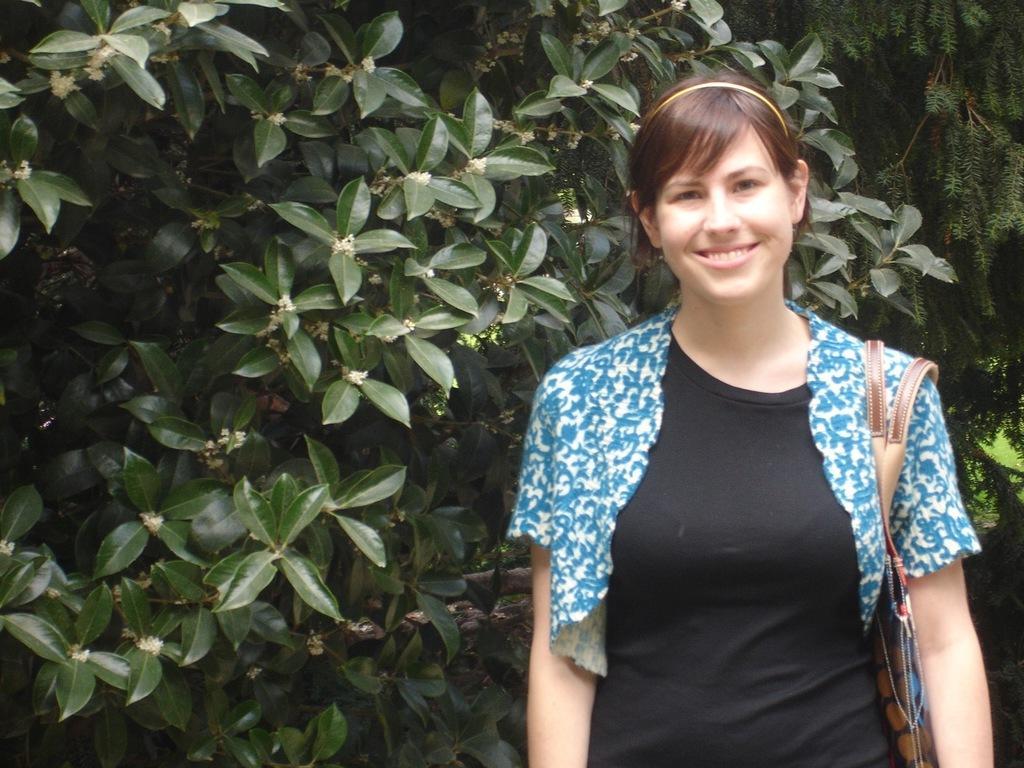How would you summarize this image in a sentence or two? In this image on the right side there is one woman who is standing and smiling and she is wearing a bag, in the background there are trees. 